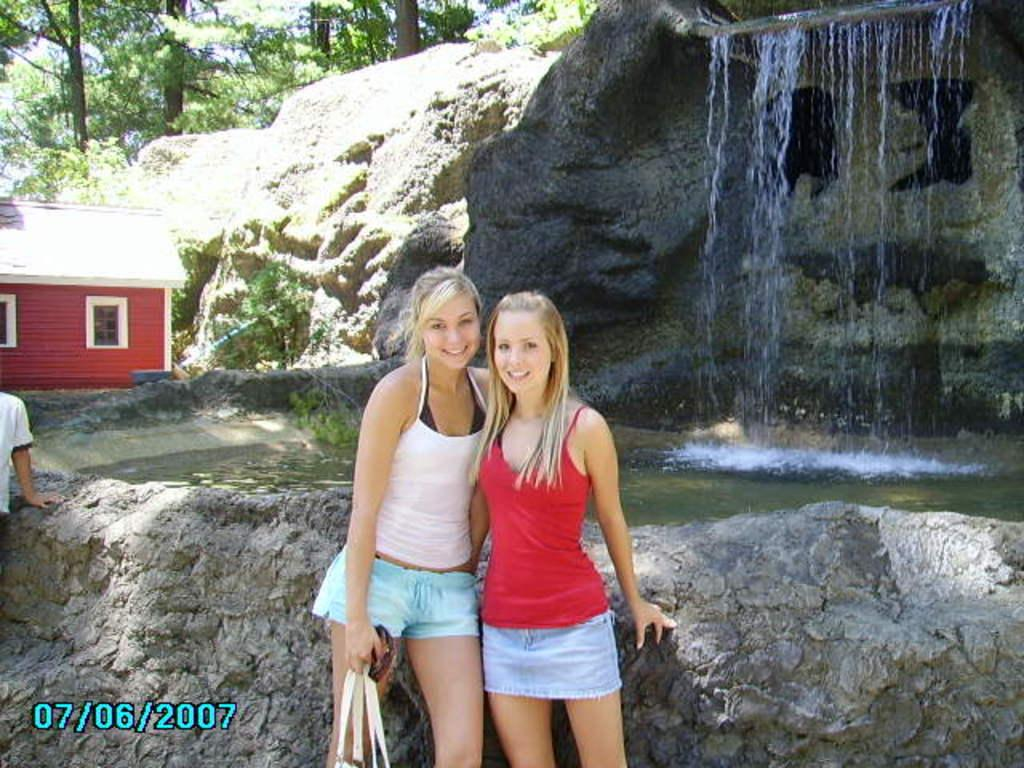<image>
Share a concise interpretation of the image provided. Two girls pose in front of a waterfall on 7/6/2007. 